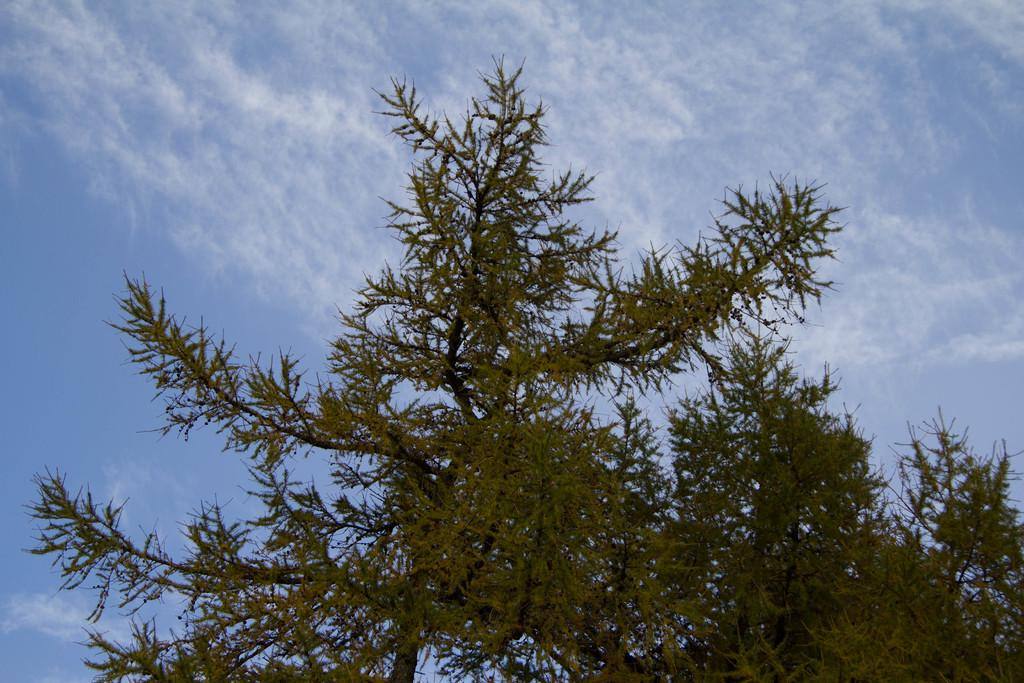What is located in the front of the image? There is a tree in the front of the image. What can be seen in the background of the image? The sky is visible in the background of the image. What type of gate can be seen in the image? There is no gate present in the image; it only features a tree and the sky. What time of day is depicted in the image, given the presence of the night? The image does not depict nighttime, as there is no mention of darkness or night in the provided facts. 